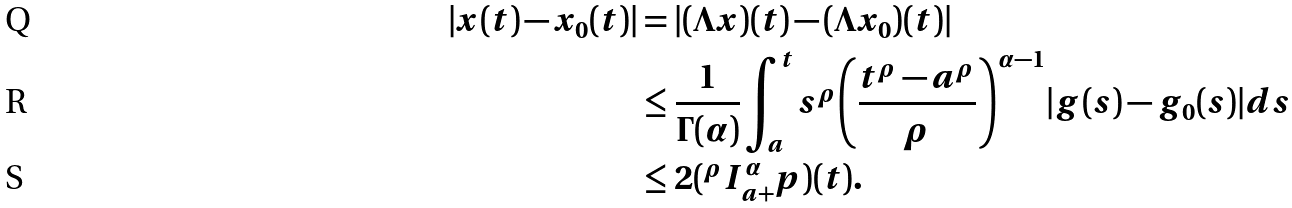<formula> <loc_0><loc_0><loc_500><loc_500>| x ( t ) - x _ { 0 } ( t ) | & = | ( \Lambda { x } ) ( t ) - ( \Lambda { x _ { 0 } } ) ( t ) | \\ & \leq \frac { 1 } { \Gamma ( \alpha ) } \int _ { a } ^ { t } s ^ { \rho } { \left ( \frac { t ^ { \rho } - a ^ { \rho } } { \rho } \right ) } ^ { \alpha - 1 } | g ( s ) - g _ { 0 } ( s ) | d s \\ & \leq 2 ( { ^ { \rho } { I } _ { a + } ^ { \alpha } p } ) ( t ) .</formula> 